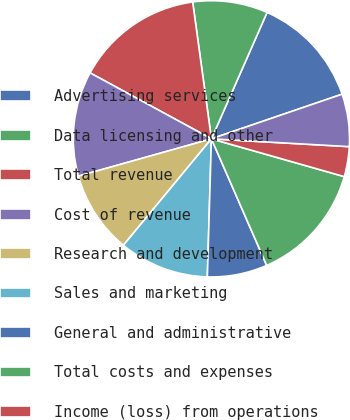Convert chart. <chart><loc_0><loc_0><loc_500><loc_500><pie_chart><fcel>Advertising services<fcel>Data licensing and other<fcel>Total revenue<fcel>Cost of revenue<fcel>Research and development<fcel>Sales and marketing<fcel>General and administrative<fcel>Total costs and expenses<fcel>Income (loss) from operations<fcel>Interest expense<nl><fcel>13.16%<fcel>8.77%<fcel>14.91%<fcel>12.28%<fcel>9.65%<fcel>10.53%<fcel>7.02%<fcel>14.04%<fcel>3.51%<fcel>6.14%<nl></chart> 